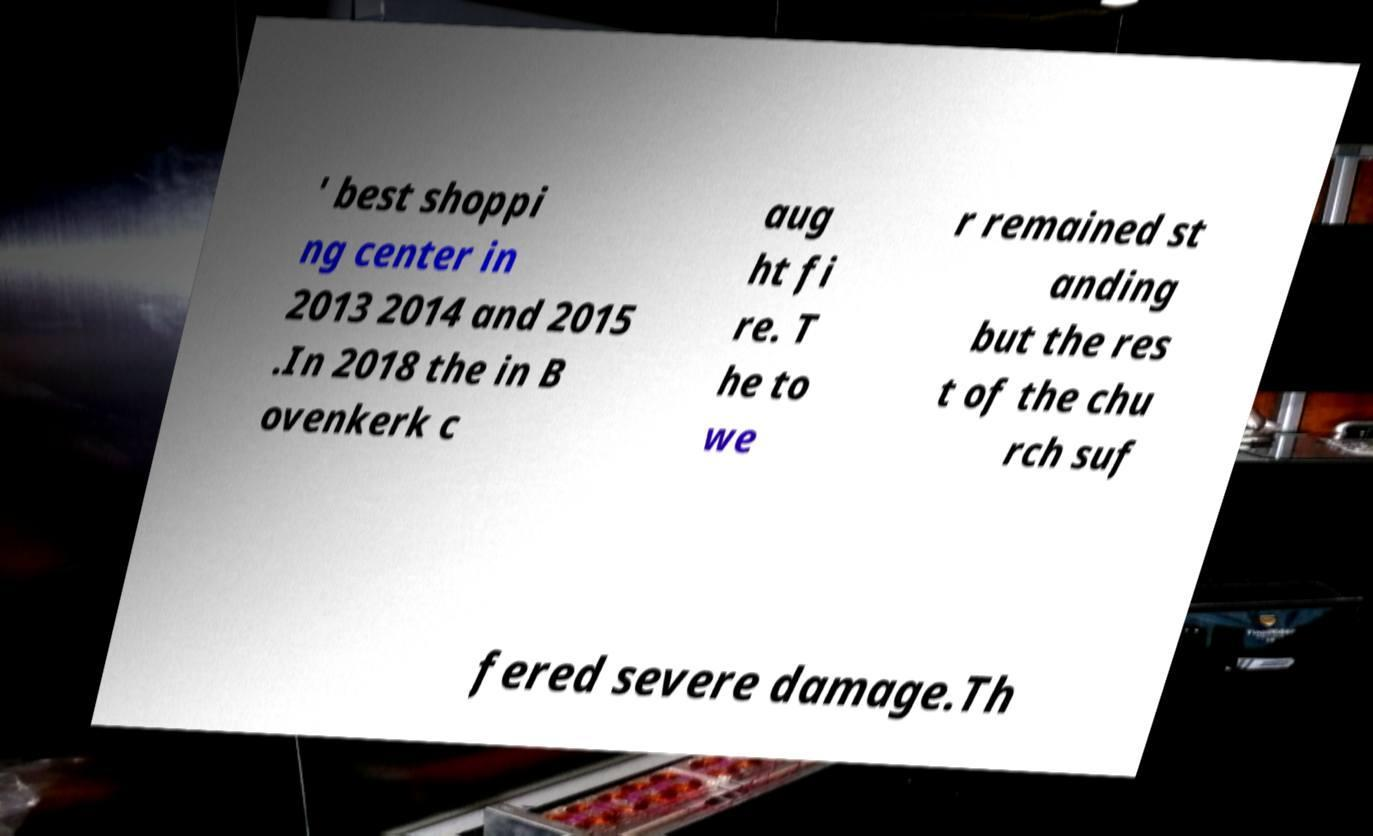What messages or text are displayed in this image? I need them in a readable, typed format. ' best shoppi ng center in 2013 2014 and 2015 .In 2018 the in B ovenkerk c aug ht fi re. T he to we r remained st anding but the res t of the chu rch suf fered severe damage.Th 